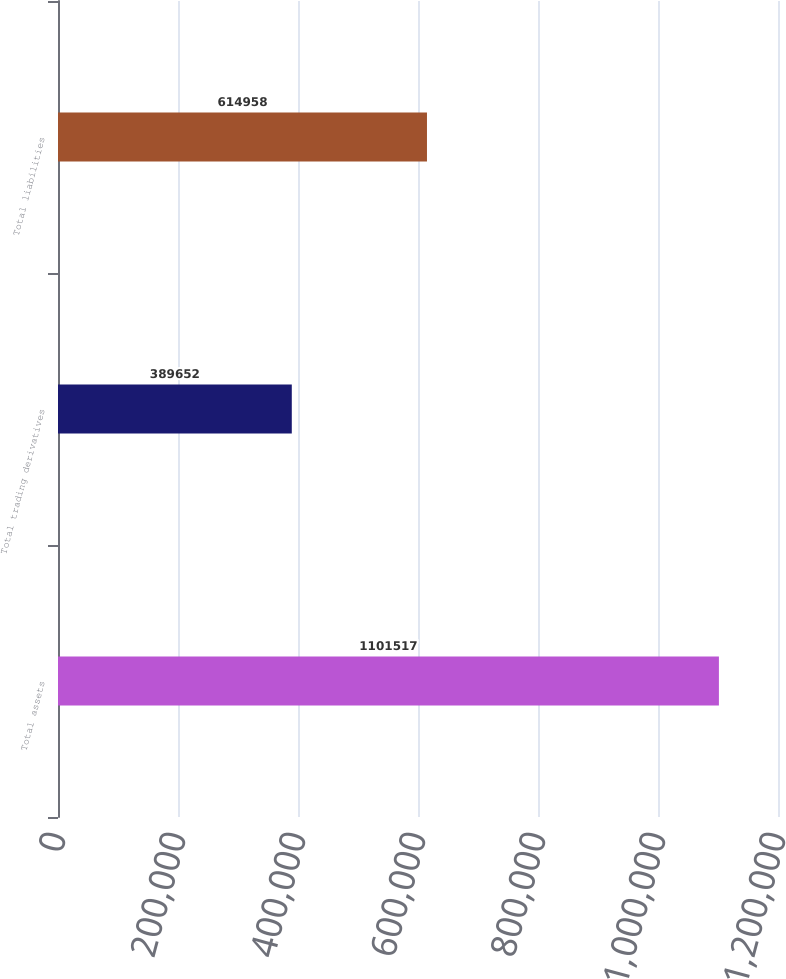Convert chart to OTSL. <chart><loc_0><loc_0><loc_500><loc_500><bar_chart><fcel>Total assets<fcel>Total trading derivatives<fcel>Total liabilities<nl><fcel>1.10152e+06<fcel>389652<fcel>614958<nl></chart> 